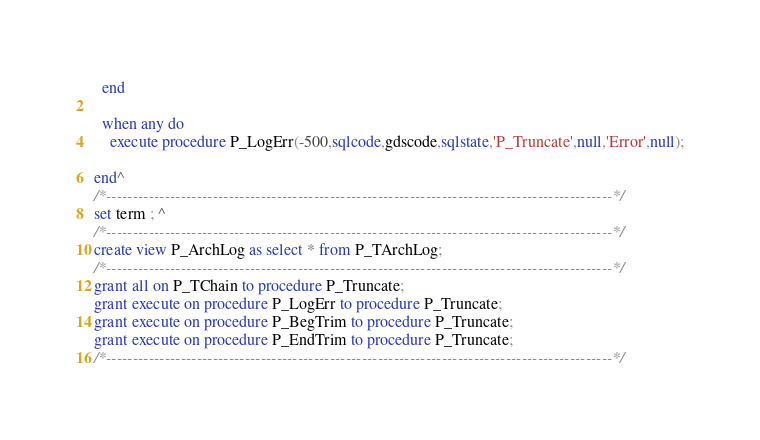<code> <loc_0><loc_0><loc_500><loc_500><_SQL_>  end

  when any do
    execute procedure P_LogErr(-500,sqlcode,gdscode,sqlstate,'P_Truncate',null,'Error',null);

end^
/*-----------------------------------------------------------------------------------------------*/
set term ; ^
/*-----------------------------------------------------------------------------------------------*/
create view P_ArchLog as select * from P_TArchLog;
/*-----------------------------------------------------------------------------------------------*/
grant all on P_TChain to procedure P_Truncate;
grant execute on procedure P_LogErr to procedure P_Truncate;
grant execute on procedure P_BegTrim to procedure P_Truncate;
grant execute on procedure P_EndTrim to procedure P_Truncate;
/*-----------------------------------------------------------------------------------------------*/


</code> 